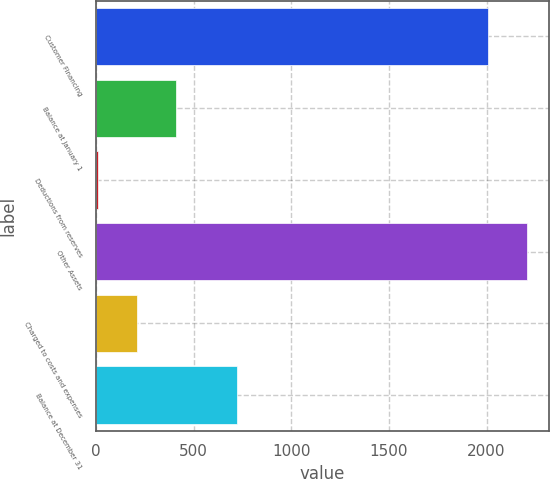Convert chart. <chart><loc_0><loc_0><loc_500><loc_500><bar_chart><fcel>Customer Financing<fcel>Balance at January 1<fcel>Deductions from reserves<fcel>Other Assets<fcel>Charged to costs and expenses<fcel>Balance at December 31<nl><fcel>2008<fcel>409.6<fcel>10<fcel>2207.8<fcel>209.8<fcel>723<nl></chart> 